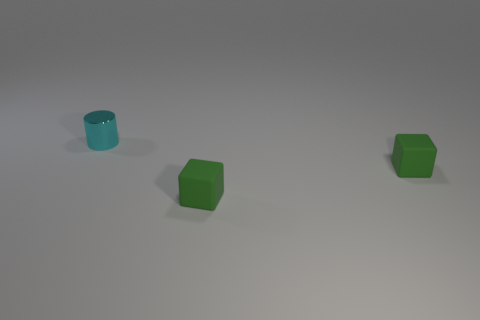Are there fewer small cyan shiny objects than yellow metal objects?
Your response must be concise. No. What number of blocks are either matte objects or metal objects?
Provide a short and direct response. 2. Is the number of objects that are behind the small cyan cylinder less than the number of tiny cyan cylinders?
Your answer should be compact. Yes. How many things are yellow matte cylinders or blocks?
Provide a succinct answer. 2. How many blocks are made of the same material as the tiny cylinder?
Offer a very short reply. 0. There is a tiny shiny thing; are there any cubes behind it?
Your response must be concise. No. What material is the small cylinder?
Make the answer very short. Metal. Are there any other things that are the same shape as the tiny cyan metallic object?
Offer a terse response. No. What is the color of the cylinder?
Your response must be concise. Cyan. Are there the same number of small cyan things that are on the right side of the cylinder and purple objects?
Give a very brief answer. Yes. 